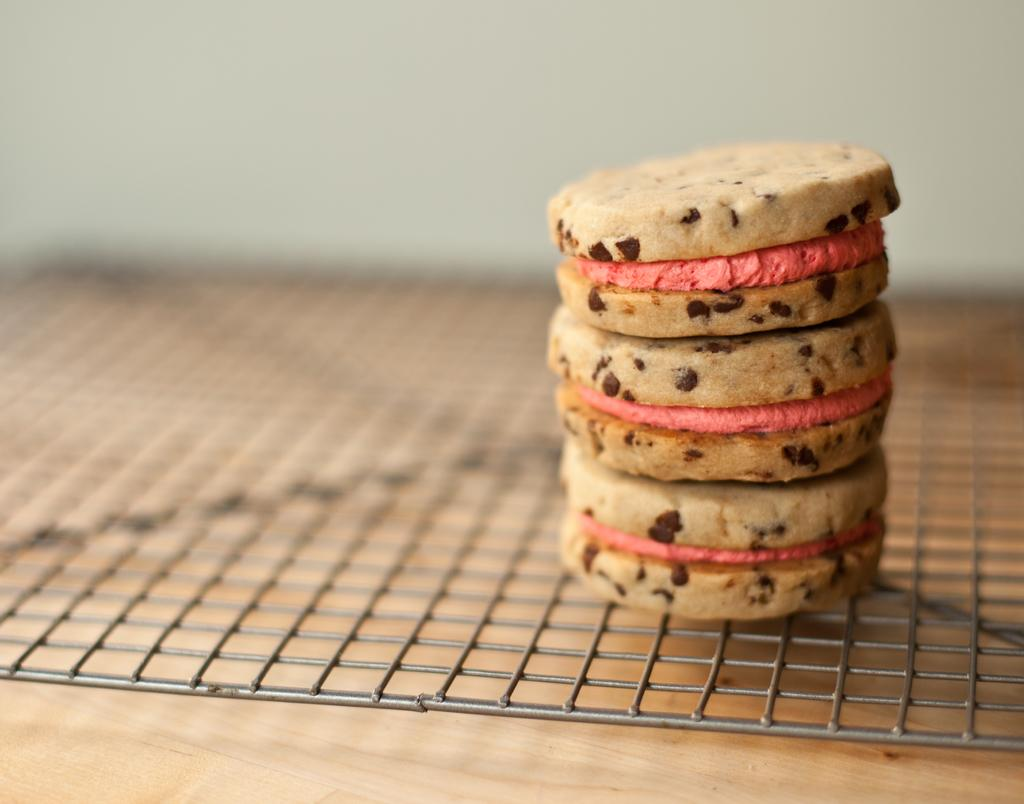What type of food is being cooked on the grill in the image? There are cookies on the grill in the image. What material is the surface at the bottom of the image made of? The surface at the bottom of the image is made of wood. What can be seen at the top of the image? There is a wall visible at the top of the image. How many cents are visible on the grill in the image? There are no cents visible on the grill in the image. What type of bells can be heard ringing in the image? There are no bells present in the image, so it is not possible to hear them ringing. 